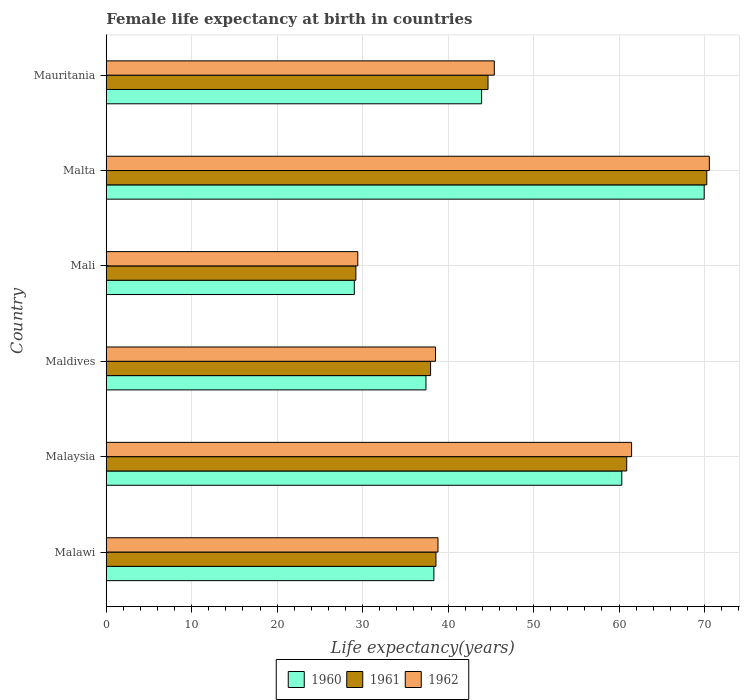How many bars are there on the 6th tick from the bottom?
Ensure brevity in your answer.  3. What is the label of the 6th group of bars from the top?
Ensure brevity in your answer.  Malawi. What is the female life expectancy at birth in 1961 in Malta?
Your answer should be compact. 70.27. Across all countries, what is the maximum female life expectancy at birth in 1961?
Ensure brevity in your answer.  70.27. Across all countries, what is the minimum female life expectancy at birth in 1961?
Give a very brief answer. 29.21. In which country was the female life expectancy at birth in 1961 maximum?
Provide a succinct answer. Malta. In which country was the female life expectancy at birth in 1960 minimum?
Offer a very short reply. Mali. What is the total female life expectancy at birth in 1962 in the graph?
Keep it short and to the point. 284.21. What is the difference between the female life expectancy at birth in 1962 in Malaysia and that in Maldives?
Provide a succinct answer. 22.95. What is the difference between the female life expectancy at birth in 1962 in Malaysia and the female life expectancy at birth in 1960 in Mauritania?
Your response must be concise. 17.55. What is the average female life expectancy at birth in 1961 per country?
Keep it short and to the point. 46.93. What is the difference between the female life expectancy at birth in 1960 and female life expectancy at birth in 1961 in Mali?
Give a very brief answer. -0.18. What is the ratio of the female life expectancy at birth in 1962 in Maldives to that in Mali?
Provide a succinct answer. 1.31. Is the difference between the female life expectancy at birth in 1960 in Malawi and Malaysia greater than the difference between the female life expectancy at birth in 1961 in Malawi and Malaysia?
Provide a succinct answer. Yes. What is the difference between the highest and the second highest female life expectancy at birth in 1960?
Make the answer very short. 9.64. What is the difference between the highest and the lowest female life expectancy at birth in 1962?
Provide a short and direct response. 41.13. In how many countries, is the female life expectancy at birth in 1962 greater than the average female life expectancy at birth in 1962 taken over all countries?
Your answer should be very brief. 2. Is it the case that in every country, the sum of the female life expectancy at birth in 1960 and female life expectancy at birth in 1962 is greater than the female life expectancy at birth in 1961?
Give a very brief answer. Yes. How many bars are there?
Your answer should be compact. 18. Are all the bars in the graph horizontal?
Offer a terse response. Yes. How many countries are there in the graph?
Offer a very short reply. 6. What is the difference between two consecutive major ticks on the X-axis?
Your answer should be very brief. 10. Are the values on the major ticks of X-axis written in scientific E-notation?
Ensure brevity in your answer.  No. Does the graph contain any zero values?
Offer a terse response. No. Does the graph contain grids?
Offer a terse response. Yes. What is the title of the graph?
Ensure brevity in your answer.  Female life expectancy at birth in countries. Does "1971" appear as one of the legend labels in the graph?
Your answer should be very brief. No. What is the label or title of the X-axis?
Offer a terse response. Life expectancy(years). What is the label or title of the Y-axis?
Offer a very short reply. Country. What is the Life expectancy(years) in 1960 in Malawi?
Make the answer very short. 38.34. What is the Life expectancy(years) of 1961 in Malawi?
Make the answer very short. 38.58. What is the Life expectancy(years) of 1962 in Malawi?
Ensure brevity in your answer.  38.82. What is the Life expectancy(years) in 1960 in Malaysia?
Provide a succinct answer. 60.32. What is the Life expectancy(years) of 1961 in Malaysia?
Make the answer very short. 60.9. What is the Life expectancy(years) of 1962 in Malaysia?
Provide a short and direct response. 61.47. What is the Life expectancy(years) in 1960 in Maldives?
Offer a very short reply. 37.41. What is the Life expectancy(years) of 1961 in Maldives?
Provide a succinct answer. 37.95. What is the Life expectancy(years) of 1962 in Maldives?
Provide a succinct answer. 38.52. What is the Life expectancy(years) in 1960 in Mali?
Offer a very short reply. 29.03. What is the Life expectancy(years) of 1961 in Mali?
Ensure brevity in your answer.  29.21. What is the Life expectancy(years) of 1962 in Mali?
Ensure brevity in your answer.  29.43. What is the Life expectancy(years) of 1960 in Malta?
Your response must be concise. 69.96. What is the Life expectancy(years) in 1961 in Malta?
Provide a succinct answer. 70.27. What is the Life expectancy(years) in 1962 in Malta?
Provide a succinct answer. 70.57. What is the Life expectancy(years) in 1960 in Mauritania?
Ensure brevity in your answer.  43.92. What is the Life expectancy(years) in 1961 in Mauritania?
Provide a short and direct response. 44.67. What is the Life expectancy(years) in 1962 in Mauritania?
Your answer should be very brief. 45.4. Across all countries, what is the maximum Life expectancy(years) of 1960?
Your response must be concise. 69.96. Across all countries, what is the maximum Life expectancy(years) of 1961?
Keep it short and to the point. 70.27. Across all countries, what is the maximum Life expectancy(years) in 1962?
Your answer should be very brief. 70.57. Across all countries, what is the minimum Life expectancy(years) in 1960?
Your answer should be very brief. 29.03. Across all countries, what is the minimum Life expectancy(years) of 1961?
Offer a very short reply. 29.21. Across all countries, what is the minimum Life expectancy(years) of 1962?
Offer a terse response. 29.43. What is the total Life expectancy(years) in 1960 in the graph?
Keep it short and to the point. 278.98. What is the total Life expectancy(years) of 1961 in the graph?
Ensure brevity in your answer.  281.58. What is the total Life expectancy(years) of 1962 in the graph?
Make the answer very short. 284.21. What is the difference between the Life expectancy(years) in 1960 in Malawi and that in Malaysia?
Ensure brevity in your answer.  -21.99. What is the difference between the Life expectancy(years) in 1961 in Malawi and that in Malaysia?
Your answer should be very brief. -22.32. What is the difference between the Life expectancy(years) of 1962 in Malawi and that in Malaysia?
Offer a very short reply. -22.65. What is the difference between the Life expectancy(years) of 1960 in Malawi and that in Maldives?
Offer a very short reply. 0.93. What is the difference between the Life expectancy(years) of 1961 in Malawi and that in Maldives?
Provide a short and direct response. 0.63. What is the difference between the Life expectancy(years) of 1962 in Malawi and that in Maldives?
Give a very brief answer. 0.29. What is the difference between the Life expectancy(years) in 1960 in Malawi and that in Mali?
Your answer should be very brief. 9.31. What is the difference between the Life expectancy(years) in 1961 in Malawi and that in Mali?
Your response must be concise. 9.37. What is the difference between the Life expectancy(years) of 1962 in Malawi and that in Mali?
Make the answer very short. 9.38. What is the difference between the Life expectancy(years) of 1960 in Malawi and that in Malta?
Provide a short and direct response. -31.63. What is the difference between the Life expectancy(years) of 1961 in Malawi and that in Malta?
Your answer should be compact. -31.69. What is the difference between the Life expectancy(years) of 1962 in Malawi and that in Malta?
Provide a short and direct response. -31.75. What is the difference between the Life expectancy(years) in 1960 in Malawi and that in Mauritania?
Your answer should be compact. -5.58. What is the difference between the Life expectancy(years) of 1961 in Malawi and that in Mauritania?
Your answer should be compact. -6.09. What is the difference between the Life expectancy(years) in 1962 in Malawi and that in Mauritania?
Offer a very short reply. -6.59. What is the difference between the Life expectancy(years) in 1960 in Malaysia and that in Maldives?
Make the answer very short. 22.91. What is the difference between the Life expectancy(years) of 1961 in Malaysia and that in Maldives?
Your answer should be compact. 22.95. What is the difference between the Life expectancy(years) in 1962 in Malaysia and that in Maldives?
Make the answer very short. 22.95. What is the difference between the Life expectancy(years) of 1960 in Malaysia and that in Mali?
Make the answer very short. 31.3. What is the difference between the Life expectancy(years) of 1961 in Malaysia and that in Mali?
Ensure brevity in your answer.  31.69. What is the difference between the Life expectancy(years) in 1962 in Malaysia and that in Mali?
Your response must be concise. 32.04. What is the difference between the Life expectancy(years) of 1960 in Malaysia and that in Malta?
Give a very brief answer. -9.64. What is the difference between the Life expectancy(years) of 1961 in Malaysia and that in Malta?
Make the answer very short. -9.37. What is the difference between the Life expectancy(years) in 1962 in Malaysia and that in Malta?
Keep it short and to the point. -9.1. What is the difference between the Life expectancy(years) of 1960 in Malaysia and that in Mauritania?
Give a very brief answer. 16.4. What is the difference between the Life expectancy(years) in 1961 in Malaysia and that in Mauritania?
Provide a short and direct response. 16.23. What is the difference between the Life expectancy(years) of 1962 in Malaysia and that in Mauritania?
Your answer should be very brief. 16.07. What is the difference between the Life expectancy(years) of 1960 in Maldives and that in Mali?
Offer a very short reply. 8.38. What is the difference between the Life expectancy(years) of 1961 in Maldives and that in Mali?
Your answer should be very brief. 8.74. What is the difference between the Life expectancy(years) of 1962 in Maldives and that in Mali?
Your response must be concise. 9.09. What is the difference between the Life expectancy(years) of 1960 in Maldives and that in Malta?
Ensure brevity in your answer.  -32.55. What is the difference between the Life expectancy(years) of 1961 in Maldives and that in Malta?
Keep it short and to the point. -32.32. What is the difference between the Life expectancy(years) of 1962 in Maldives and that in Malta?
Provide a short and direct response. -32.04. What is the difference between the Life expectancy(years) of 1960 in Maldives and that in Mauritania?
Make the answer very short. -6.51. What is the difference between the Life expectancy(years) in 1961 in Maldives and that in Mauritania?
Give a very brief answer. -6.72. What is the difference between the Life expectancy(years) of 1962 in Maldives and that in Mauritania?
Keep it short and to the point. -6.88. What is the difference between the Life expectancy(years) in 1960 in Mali and that in Malta?
Your answer should be very brief. -40.94. What is the difference between the Life expectancy(years) of 1961 in Mali and that in Malta?
Provide a succinct answer. -41.06. What is the difference between the Life expectancy(years) in 1962 in Mali and that in Malta?
Offer a very short reply. -41.13. What is the difference between the Life expectancy(years) in 1960 in Mali and that in Mauritania?
Provide a succinct answer. -14.89. What is the difference between the Life expectancy(years) of 1961 in Mali and that in Mauritania?
Keep it short and to the point. -15.46. What is the difference between the Life expectancy(years) of 1962 in Mali and that in Mauritania?
Make the answer very short. -15.97. What is the difference between the Life expectancy(years) of 1960 in Malta and that in Mauritania?
Your response must be concise. 26.04. What is the difference between the Life expectancy(years) in 1961 in Malta and that in Mauritania?
Ensure brevity in your answer.  25.6. What is the difference between the Life expectancy(years) of 1962 in Malta and that in Mauritania?
Offer a very short reply. 25.16. What is the difference between the Life expectancy(years) in 1960 in Malawi and the Life expectancy(years) in 1961 in Malaysia?
Your answer should be compact. -22.56. What is the difference between the Life expectancy(years) of 1960 in Malawi and the Life expectancy(years) of 1962 in Malaysia?
Provide a succinct answer. -23.14. What is the difference between the Life expectancy(years) of 1961 in Malawi and the Life expectancy(years) of 1962 in Malaysia?
Provide a short and direct response. -22.89. What is the difference between the Life expectancy(years) of 1960 in Malawi and the Life expectancy(years) of 1961 in Maldives?
Your answer should be compact. 0.39. What is the difference between the Life expectancy(years) of 1960 in Malawi and the Life expectancy(years) of 1962 in Maldives?
Offer a very short reply. -0.19. What is the difference between the Life expectancy(years) of 1961 in Malawi and the Life expectancy(years) of 1962 in Maldives?
Provide a succinct answer. 0.06. What is the difference between the Life expectancy(years) of 1960 in Malawi and the Life expectancy(years) of 1961 in Mali?
Keep it short and to the point. 9.12. What is the difference between the Life expectancy(years) in 1960 in Malawi and the Life expectancy(years) in 1962 in Mali?
Ensure brevity in your answer.  8.9. What is the difference between the Life expectancy(years) of 1961 in Malawi and the Life expectancy(years) of 1962 in Mali?
Give a very brief answer. 9.15. What is the difference between the Life expectancy(years) of 1960 in Malawi and the Life expectancy(years) of 1961 in Malta?
Ensure brevity in your answer.  -31.93. What is the difference between the Life expectancy(years) of 1960 in Malawi and the Life expectancy(years) of 1962 in Malta?
Make the answer very short. -32.23. What is the difference between the Life expectancy(years) of 1961 in Malawi and the Life expectancy(years) of 1962 in Malta?
Your response must be concise. -31.99. What is the difference between the Life expectancy(years) in 1960 in Malawi and the Life expectancy(years) in 1961 in Mauritania?
Give a very brief answer. -6.34. What is the difference between the Life expectancy(years) in 1960 in Malawi and the Life expectancy(years) in 1962 in Mauritania?
Offer a very short reply. -7.07. What is the difference between the Life expectancy(years) in 1961 in Malawi and the Life expectancy(years) in 1962 in Mauritania?
Your answer should be very brief. -6.82. What is the difference between the Life expectancy(years) of 1960 in Malaysia and the Life expectancy(years) of 1961 in Maldives?
Ensure brevity in your answer.  22.37. What is the difference between the Life expectancy(years) in 1960 in Malaysia and the Life expectancy(years) in 1962 in Maldives?
Provide a succinct answer. 21.8. What is the difference between the Life expectancy(years) of 1961 in Malaysia and the Life expectancy(years) of 1962 in Maldives?
Give a very brief answer. 22.38. What is the difference between the Life expectancy(years) of 1960 in Malaysia and the Life expectancy(years) of 1961 in Mali?
Ensure brevity in your answer.  31.11. What is the difference between the Life expectancy(years) of 1960 in Malaysia and the Life expectancy(years) of 1962 in Mali?
Offer a very short reply. 30.89. What is the difference between the Life expectancy(years) of 1961 in Malaysia and the Life expectancy(years) of 1962 in Mali?
Your answer should be very brief. 31.47. What is the difference between the Life expectancy(years) of 1960 in Malaysia and the Life expectancy(years) of 1961 in Malta?
Provide a short and direct response. -9.95. What is the difference between the Life expectancy(years) in 1960 in Malaysia and the Life expectancy(years) in 1962 in Malta?
Your response must be concise. -10.24. What is the difference between the Life expectancy(years) of 1961 in Malaysia and the Life expectancy(years) of 1962 in Malta?
Your answer should be very brief. -9.67. What is the difference between the Life expectancy(years) in 1960 in Malaysia and the Life expectancy(years) in 1961 in Mauritania?
Your answer should be very brief. 15.65. What is the difference between the Life expectancy(years) in 1960 in Malaysia and the Life expectancy(years) in 1962 in Mauritania?
Make the answer very short. 14.92. What is the difference between the Life expectancy(years) of 1961 in Malaysia and the Life expectancy(years) of 1962 in Mauritania?
Offer a very short reply. 15.49. What is the difference between the Life expectancy(years) of 1960 in Maldives and the Life expectancy(years) of 1962 in Mali?
Keep it short and to the point. 7.98. What is the difference between the Life expectancy(years) of 1961 in Maldives and the Life expectancy(years) of 1962 in Mali?
Offer a very short reply. 8.52. What is the difference between the Life expectancy(years) of 1960 in Maldives and the Life expectancy(years) of 1961 in Malta?
Make the answer very short. -32.86. What is the difference between the Life expectancy(years) in 1960 in Maldives and the Life expectancy(years) in 1962 in Malta?
Keep it short and to the point. -33.16. What is the difference between the Life expectancy(years) of 1961 in Maldives and the Life expectancy(years) of 1962 in Malta?
Provide a short and direct response. -32.62. What is the difference between the Life expectancy(years) in 1960 in Maldives and the Life expectancy(years) in 1961 in Mauritania?
Your response must be concise. -7.26. What is the difference between the Life expectancy(years) of 1960 in Maldives and the Life expectancy(years) of 1962 in Mauritania?
Keep it short and to the point. -7.99. What is the difference between the Life expectancy(years) of 1961 in Maldives and the Life expectancy(years) of 1962 in Mauritania?
Make the answer very short. -7.45. What is the difference between the Life expectancy(years) in 1960 in Mali and the Life expectancy(years) in 1961 in Malta?
Your answer should be very brief. -41.24. What is the difference between the Life expectancy(years) in 1960 in Mali and the Life expectancy(years) in 1962 in Malta?
Provide a short and direct response. -41.54. What is the difference between the Life expectancy(years) in 1961 in Mali and the Life expectancy(years) in 1962 in Malta?
Give a very brief answer. -41.36. What is the difference between the Life expectancy(years) in 1960 in Mali and the Life expectancy(years) in 1961 in Mauritania?
Provide a succinct answer. -15.64. What is the difference between the Life expectancy(years) of 1960 in Mali and the Life expectancy(years) of 1962 in Mauritania?
Give a very brief answer. -16.38. What is the difference between the Life expectancy(years) in 1961 in Mali and the Life expectancy(years) in 1962 in Mauritania?
Your response must be concise. -16.19. What is the difference between the Life expectancy(years) of 1960 in Malta and the Life expectancy(years) of 1961 in Mauritania?
Your answer should be very brief. 25.29. What is the difference between the Life expectancy(years) of 1960 in Malta and the Life expectancy(years) of 1962 in Mauritania?
Offer a terse response. 24.56. What is the difference between the Life expectancy(years) of 1961 in Malta and the Life expectancy(years) of 1962 in Mauritania?
Your answer should be compact. 24.86. What is the average Life expectancy(years) in 1960 per country?
Keep it short and to the point. 46.5. What is the average Life expectancy(years) of 1961 per country?
Offer a very short reply. 46.93. What is the average Life expectancy(years) of 1962 per country?
Ensure brevity in your answer.  47.37. What is the difference between the Life expectancy(years) in 1960 and Life expectancy(years) in 1961 in Malawi?
Provide a succinct answer. -0.24. What is the difference between the Life expectancy(years) of 1960 and Life expectancy(years) of 1962 in Malawi?
Give a very brief answer. -0.48. What is the difference between the Life expectancy(years) in 1961 and Life expectancy(years) in 1962 in Malawi?
Your answer should be compact. -0.24. What is the difference between the Life expectancy(years) of 1960 and Life expectancy(years) of 1961 in Malaysia?
Keep it short and to the point. -0.58. What is the difference between the Life expectancy(years) of 1960 and Life expectancy(years) of 1962 in Malaysia?
Your answer should be compact. -1.15. What is the difference between the Life expectancy(years) of 1961 and Life expectancy(years) of 1962 in Malaysia?
Ensure brevity in your answer.  -0.57. What is the difference between the Life expectancy(years) in 1960 and Life expectancy(years) in 1961 in Maldives?
Offer a very short reply. -0.54. What is the difference between the Life expectancy(years) in 1960 and Life expectancy(years) in 1962 in Maldives?
Ensure brevity in your answer.  -1.11. What is the difference between the Life expectancy(years) in 1961 and Life expectancy(years) in 1962 in Maldives?
Offer a terse response. -0.57. What is the difference between the Life expectancy(years) of 1960 and Life expectancy(years) of 1961 in Mali?
Offer a very short reply. -0.18. What is the difference between the Life expectancy(years) of 1960 and Life expectancy(years) of 1962 in Mali?
Keep it short and to the point. -0.41. What is the difference between the Life expectancy(years) of 1961 and Life expectancy(years) of 1962 in Mali?
Give a very brief answer. -0.22. What is the difference between the Life expectancy(years) in 1960 and Life expectancy(years) in 1961 in Malta?
Give a very brief answer. -0.3. What is the difference between the Life expectancy(years) in 1960 and Life expectancy(years) in 1962 in Malta?
Your response must be concise. -0.6. What is the difference between the Life expectancy(years) in 1961 and Life expectancy(years) in 1962 in Malta?
Keep it short and to the point. -0.3. What is the difference between the Life expectancy(years) in 1960 and Life expectancy(years) in 1961 in Mauritania?
Provide a succinct answer. -0.75. What is the difference between the Life expectancy(years) in 1960 and Life expectancy(years) in 1962 in Mauritania?
Give a very brief answer. -1.48. What is the difference between the Life expectancy(years) in 1961 and Life expectancy(years) in 1962 in Mauritania?
Offer a terse response. -0.73. What is the ratio of the Life expectancy(years) of 1960 in Malawi to that in Malaysia?
Make the answer very short. 0.64. What is the ratio of the Life expectancy(years) of 1961 in Malawi to that in Malaysia?
Provide a succinct answer. 0.63. What is the ratio of the Life expectancy(years) of 1962 in Malawi to that in Malaysia?
Provide a succinct answer. 0.63. What is the ratio of the Life expectancy(years) of 1960 in Malawi to that in Maldives?
Your response must be concise. 1.02. What is the ratio of the Life expectancy(years) in 1961 in Malawi to that in Maldives?
Provide a succinct answer. 1.02. What is the ratio of the Life expectancy(years) of 1962 in Malawi to that in Maldives?
Ensure brevity in your answer.  1.01. What is the ratio of the Life expectancy(years) of 1960 in Malawi to that in Mali?
Keep it short and to the point. 1.32. What is the ratio of the Life expectancy(years) of 1961 in Malawi to that in Mali?
Your answer should be compact. 1.32. What is the ratio of the Life expectancy(years) of 1962 in Malawi to that in Mali?
Your response must be concise. 1.32. What is the ratio of the Life expectancy(years) in 1960 in Malawi to that in Malta?
Provide a short and direct response. 0.55. What is the ratio of the Life expectancy(years) of 1961 in Malawi to that in Malta?
Ensure brevity in your answer.  0.55. What is the ratio of the Life expectancy(years) in 1962 in Malawi to that in Malta?
Your answer should be very brief. 0.55. What is the ratio of the Life expectancy(years) of 1960 in Malawi to that in Mauritania?
Keep it short and to the point. 0.87. What is the ratio of the Life expectancy(years) of 1961 in Malawi to that in Mauritania?
Your answer should be compact. 0.86. What is the ratio of the Life expectancy(years) of 1962 in Malawi to that in Mauritania?
Provide a succinct answer. 0.85. What is the ratio of the Life expectancy(years) of 1960 in Malaysia to that in Maldives?
Your answer should be very brief. 1.61. What is the ratio of the Life expectancy(years) of 1961 in Malaysia to that in Maldives?
Your answer should be compact. 1.6. What is the ratio of the Life expectancy(years) in 1962 in Malaysia to that in Maldives?
Your answer should be very brief. 1.6. What is the ratio of the Life expectancy(years) in 1960 in Malaysia to that in Mali?
Keep it short and to the point. 2.08. What is the ratio of the Life expectancy(years) of 1961 in Malaysia to that in Mali?
Provide a succinct answer. 2.08. What is the ratio of the Life expectancy(years) in 1962 in Malaysia to that in Mali?
Your answer should be very brief. 2.09. What is the ratio of the Life expectancy(years) of 1960 in Malaysia to that in Malta?
Offer a terse response. 0.86. What is the ratio of the Life expectancy(years) in 1961 in Malaysia to that in Malta?
Make the answer very short. 0.87. What is the ratio of the Life expectancy(years) of 1962 in Malaysia to that in Malta?
Make the answer very short. 0.87. What is the ratio of the Life expectancy(years) in 1960 in Malaysia to that in Mauritania?
Your answer should be very brief. 1.37. What is the ratio of the Life expectancy(years) in 1961 in Malaysia to that in Mauritania?
Give a very brief answer. 1.36. What is the ratio of the Life expectancy(years) in 1962 in Malaysia to that in Mauritania?
Give a very brief answer. 1.35. What is the ratio of the Life expectancy(years) in 1960 in Maldives to that in Mali?
Keep it short and to the point. 1.29. What is the ratio of the Life expectancy(years) of 1961 in Maldives to that in Mali?
Make the answer very short. 1.3. What is the ratio of the Life expectancy(years) in 1962 in Maldives to that in Mali?
Your response must be concise. 1.31. What is the ratio of the Life expectancy(years) of 1960 in Maldives to that in Malta?
Offer a very short reply. 0.53. What is the ratio of the Life expectancy(years) in 1961 in Maldives to that in Malta?
Your answer should be very brief. 0.54. What is the ratio of the Life expectancy(years) in 1962 in Maldives to that in Malta?
Keep it short and to the point. 0.55. What is the ratio of the Life expectancy(years) in 1960 in Maldives to that in Mauritania?
Keep it short and to the point. 0.85. What is the ratio of the Life expectancy(years) of 1961 in Maldives to that in Mauritania?
Your answer should be very brief. 0.85. What is the ratio of the Life expectancy(years) of 1962 in Maldives to that in Mauritania?
Provide a short and direct response. 0.85. What is the ratio of the Life expectancy(years) in 1960 in Mali to that in Malta?
Your response must be concise. 0.41. What is the ratio of the Life expectancy(years) of 1961 in Mali to that in Malta?
Your answer should be very brief. 0.42. What is the ratio of the Life expectancy(years) in 1962 in Mali to that in Malta?
Keep it short and to the point. 0.42. What is the ratio of the Life expectancy(years) in 1960 in Mali to that in Mauritania?
Keep it short and to the point. 0.66. What is the ratio of the Life expectancy(years) in 1961 in Mali to that in Mauritania?
Offer a terse response. 0.65. What is the ratio of the Life expectancy(years) in 1962 in Mali to that in Mauritania?
Your answer should be very brief. 0.65. What is the ratio of the Life expectancy(years) in 1960 in Malta to that in Mauritania?
Provide a succinct answer. 1.59. What is the ratio of the Life expectancy(years) of 1961 in Malta to that in Mauritania?
Make the answer very short. 1.57. What is the ratio of the Life expectancy(years) in 1962 in Malta to that in Mauritania?
Give a very brief answer. 1.55. What is the difference between the highest and the second highest Life expectancy(years) in 1960?
Ensure brevity in your answer.  9.64. What is the difference between the highest and the second highest Life expectancy(years) in 1961?
Offer a very short reply. 9.37. What is the difference between the highest and the second highest Life expectancy(years) of 1962?
Keep it short and to the point. 9.1. What is the difference between the highest and the lowest Life expectancy(years) of 1960?
Ensure brevity in your answer.  40.94. What is the difference between the highest and the lowest Life expectancy(years) in 1961?
Your answer should be compact. 41.06. What is the difference between the highest and the lowest Life expectancy(years) of 1962?
Your response must be concise. 41.13. 